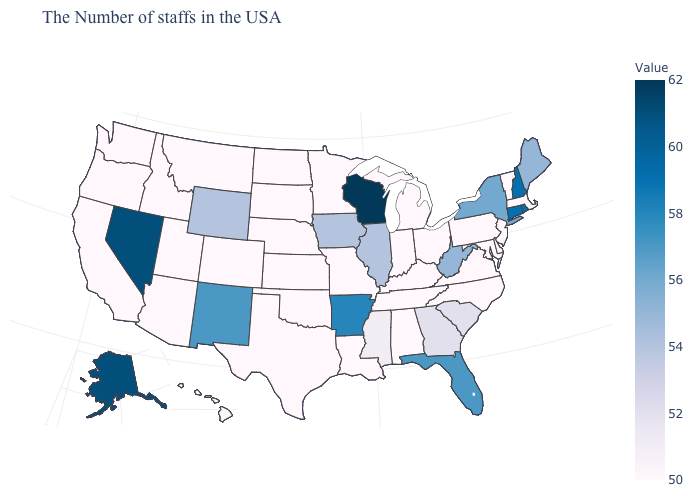Which states have the lowest value in the West?
Give a very brief answer. Colorado, Utah, Montana, Arizona, Idaho, California, Washington, Oregon, Hawaii. Which states have the lowest value in the South?
Write a very short answer. Delaware, Maryland, Virginia, North Carolina, Kentucky, Alabama, Tennessee, Louisiana, Oklahoma, Texas. Is the legend a continuous bar?
Short answer required. Yes. Does Michigan have a higher value than Arkansas?
Short answer required. No. 